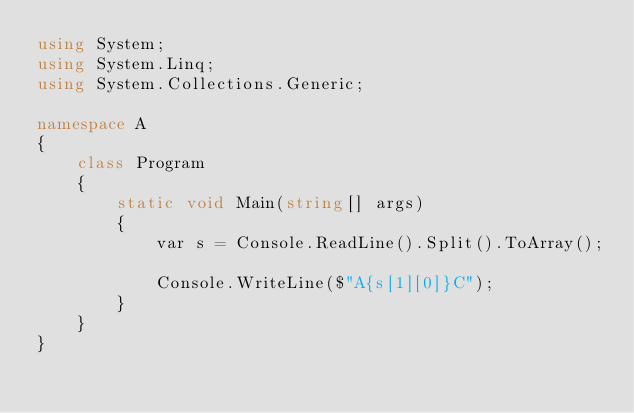<code> <loc_0><loc_0><loc_500><loc_500><_C#_>using System;
using System.Linq;
using System.Collections.Generic;

namespace A
{
    class Program
    {
        static void Main(string[] args)
        {
            var s = Console.ReadLine().Split().ToArray();

            Console.WriteLine($"A{s[1][0]}C");
        }
    }
}
</code> 